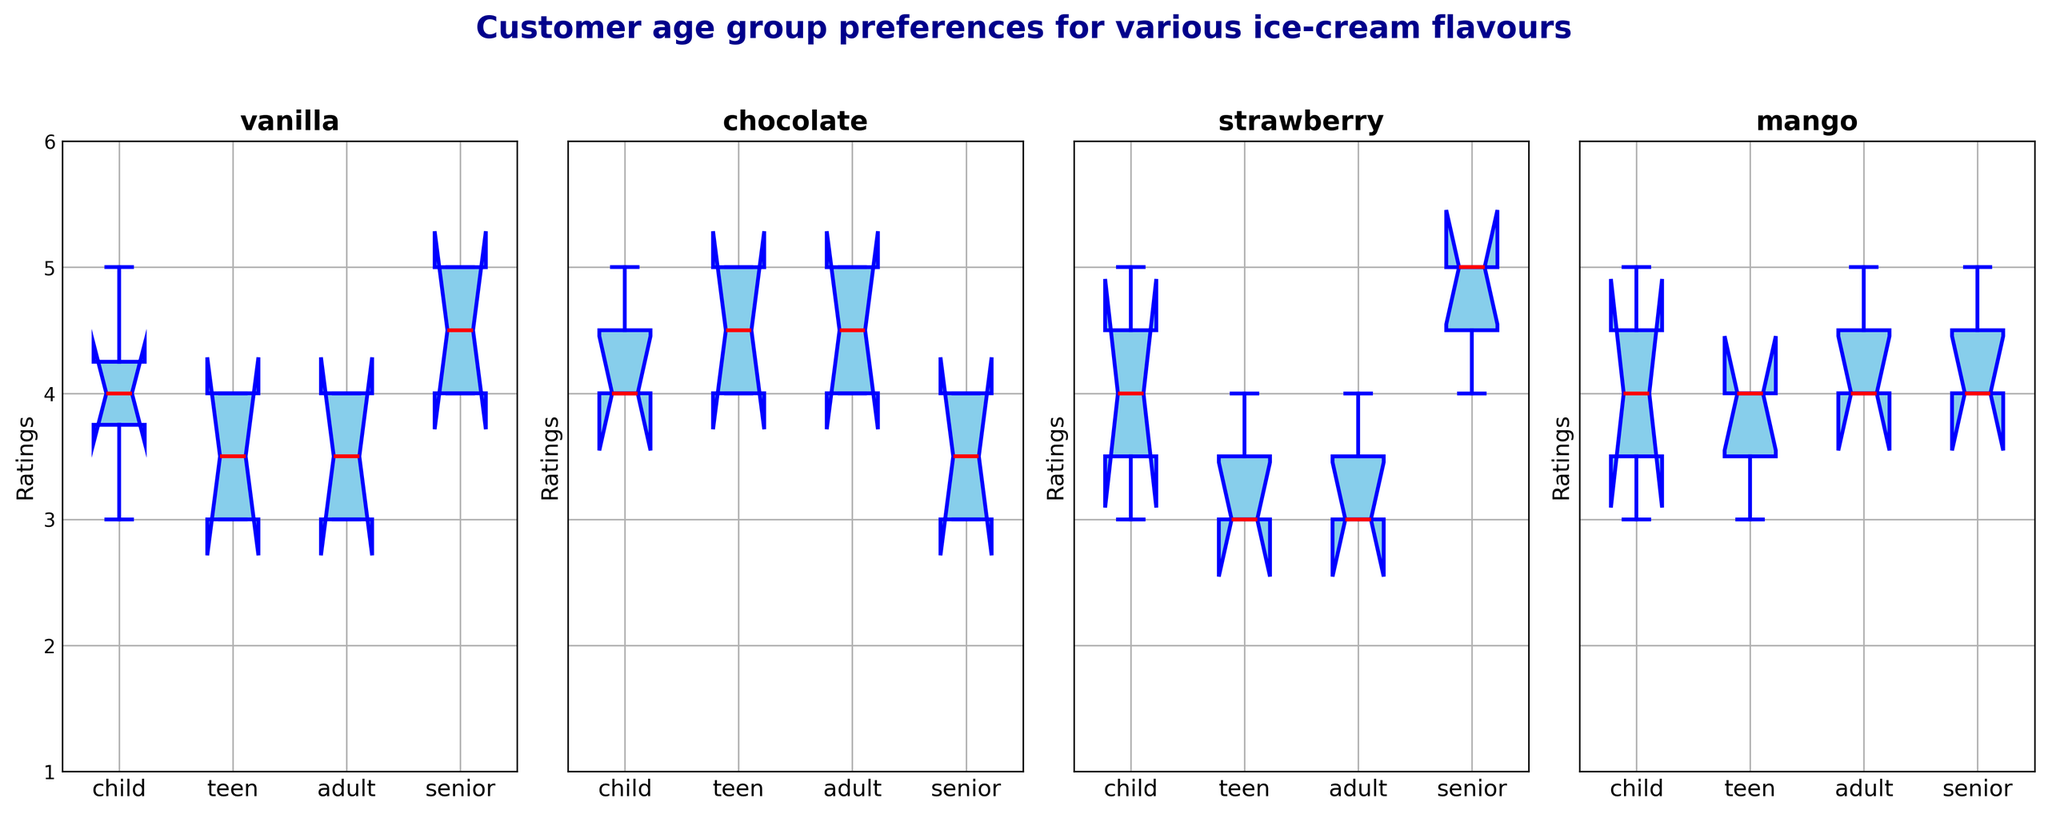Which age group has the highest median rating for vanilla? To find the highest median rating for vanilla, locate the red line inside the vanilla box corresponding to each age group. The seniors’ box has the highest red line (median rating).
Answer: senior What is the difference between the median rating for chocolate by adults and children? Check the median line inside the box of the chocolate flavor for both adults and children. The adults' median is 4.5 and the children's median is 4. The difference is 4.5 - 4.
Answer: 0.5 Which flavour has the most consistent ratings for teens? To determine consistency, observe the length of the boxes. The shorter the box, the more consistent the ratings. For teens, the chocolate flavor box is the shortest.
Answer: chocolate Compare the median ratings for mango between adults and seniors. Which age group gives a higher rating? Look at the red line (median) within the mango box for both adults and seniors. Both boxes have the same median line height at 4.5.
Answer: equal Which flavor has the widest range of ratings for children? The range can be determined by the distance between the bottom and top whiskers. For children, the chocolate flavor’s box has the widest range.
Answer: chocolate What is the median rating for strawberry across all age groups? Observe the median lines within the strawberry boxes for each age group (children, teens, adults, seniors). They are all at 4. Summing them up gives (4+4+4+4)/4 = 4.
Answer: 4 How do the quartiles of mango ratings for adults compare to the ratings for seniors? Compare the lengths and positions of the boxes (bottom and top of the boxes represent Q1 and Q3). The quartiles (Q1 and Q3) are identical for both adults and seniors, indicating both boxes have similar spread between quartiles.
Answer: equal Which age group shows the most variability in ratings for strawberry? Variability can be observed through the total range (whiskers) and interquartile range (box size). For strawberry, children show the longest whiskers, indicating the highest variability.
Answer: child 